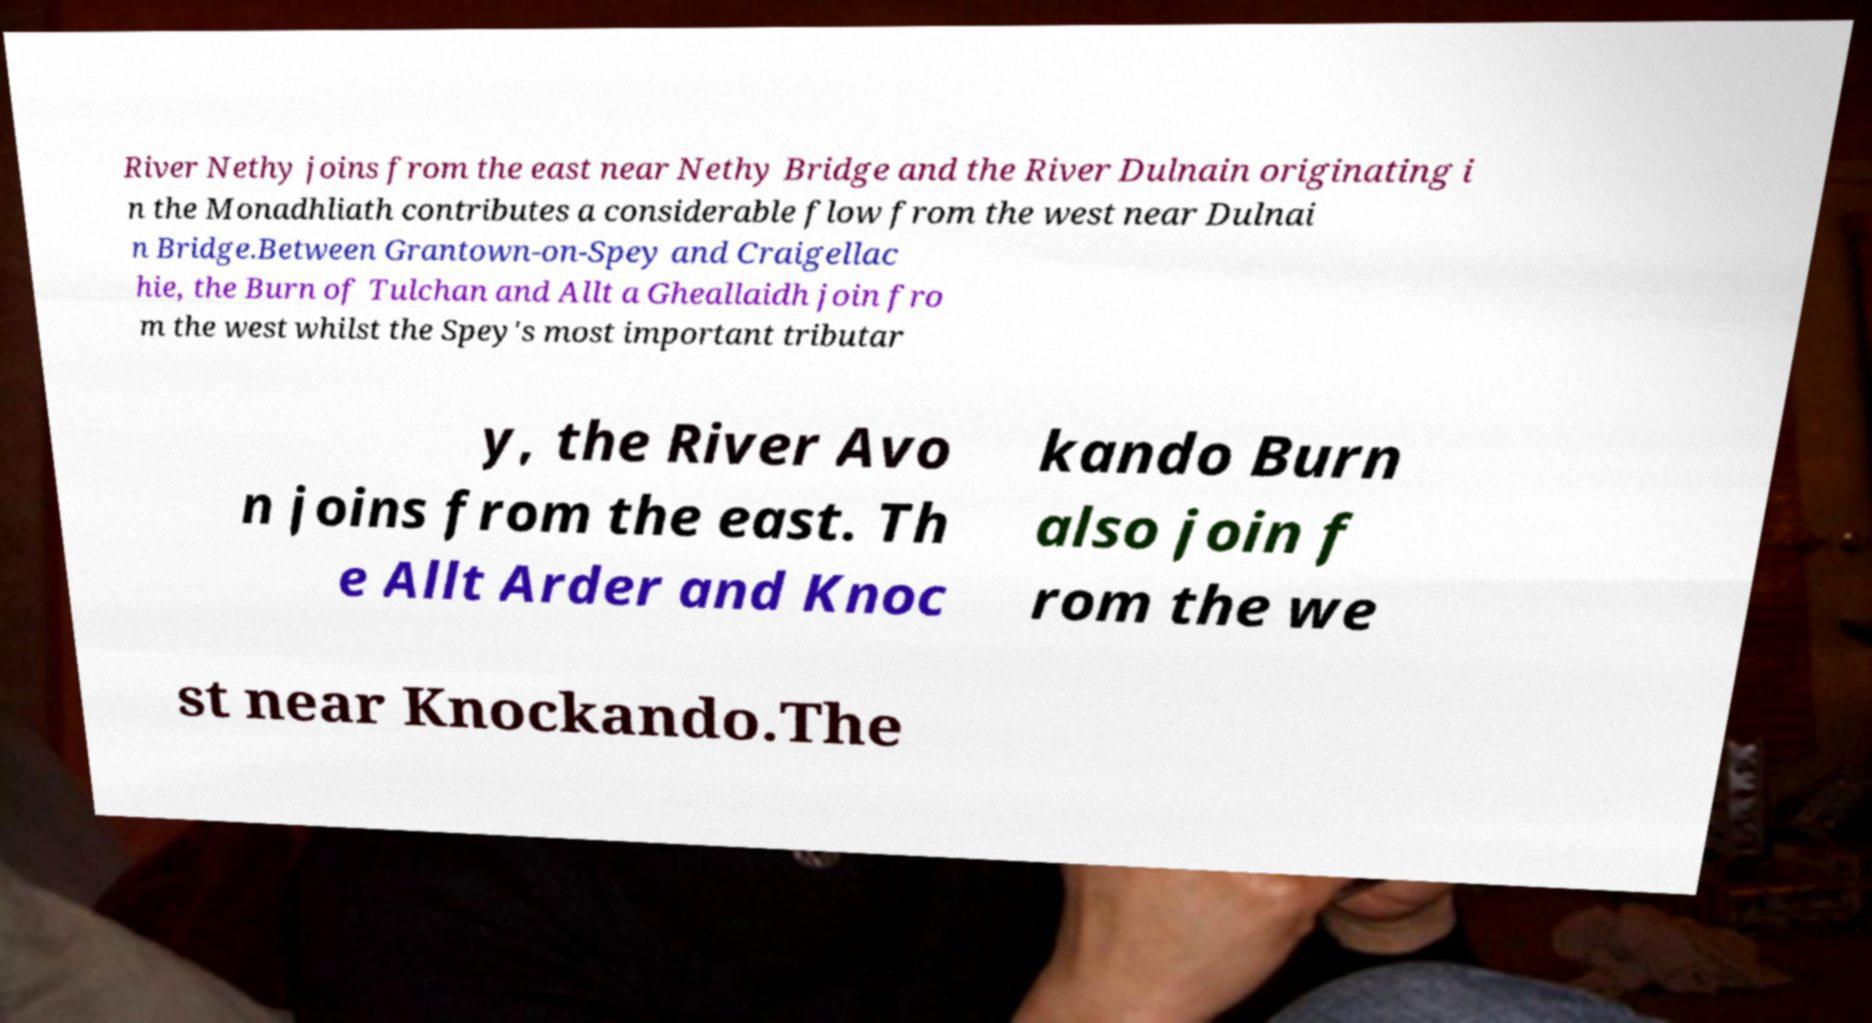Please identify and transcribe the text found in this image. River Nethy joins from the east near Nethy Bridge and the River Dulnain originating i n the Monadhliath contributes a considerable flow from the west near Dulnai n Bridge.Between Grantown-on-Spey and Craigellac hie, the Burn of Tulchan and Allt a Gheallaidh join fro m the west whilst the Spey's most important tributar y, the River Avo n joins from the east. Th e Allt Arder and Knoc kando Burn also join f rom the we st near Knockando.The 